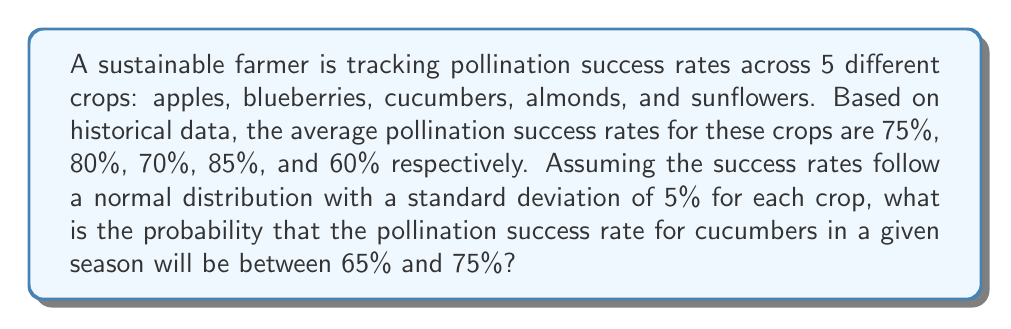What is the answer to this math problem? To solve this problem, we'll use the properties of the normal distribution and the z-score formula.

Step 1: Identify the given information
- Cucumber pollination success rate: mean (μ) = 70%
- Standard deviation (σ) = 5%
- We want to find the probability of success rate between 65% and 75%

Step 2: Calculate the z-scores for the lower and upper bounds
z-score formula: $z = \frac{x - \mu}{\sigma}$

For 65%: $z_1 = \frac{65 - 70}{5} = -1$
For 75%: $z_2 = \frac{75 - 70}{5} = 1$

Step 3: Use the standard normal distribution table or a calculator to find the area between these z-scores

The probability is equal to the area between z = -1 and z = 1 under the standard normal curve.

This can be calculated as:
$P(-1 < Z < 1) = P(Z < 1) - P(Z < -1)$

Using a standard normal table or calculator:
$P(Z < 1) \approx 0.8413$
$P(Z < -1) \approx 0.1587$

Step 4: Calculate the final probability
$P(-1 < Z < 1) = 0.8413 - 0.1587 = 0.6826$

Therefore, the probability that the pollination success rate for cucumbers will be between 65% and 75% is approximately 0.6826 or 68.26%.
Answer: 0.6826 (or 68.26%) 